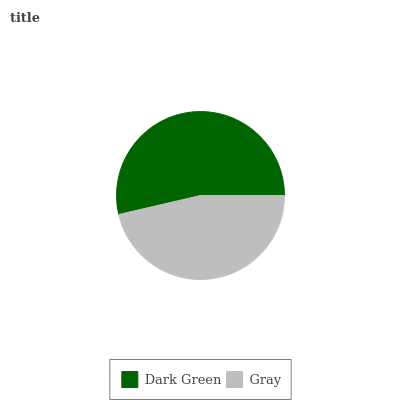Is Gray the minimum?
Answer yes or no. Yes. Is Dark Green the maximum?
Answer yes or no. Yes. Is Gray the maximum?
Answer yes or no. No. Is Dark Green greater than Gray?
Answer yes or no. Yes. Is Gray less than Dark Green?
Answer yes or no. Yes. Is Gray greater than Dark Green?
Answer yes or no. No. Is Dark Green less than Gray?
Answer yes or no. No. Is Dark Green the high median?
Answer yes or no. Yes. Is Gray the low median?
Answer yes or no. Yes. Is Gray the high median?
Answer yes or no. No. Is Dark Green the low median?
Answer yes or no. No. 